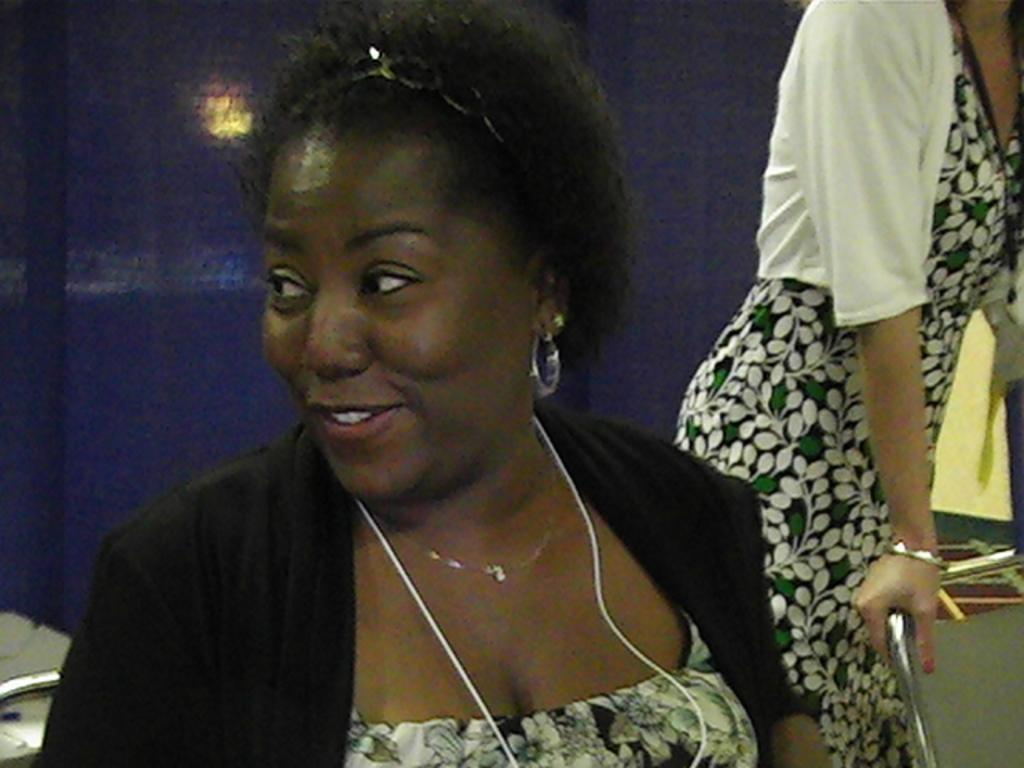How many people are in the image? There are persons in the image. What are the persons wearing? The persons are wearing clothes. Can you describe the position of a person in the image? There is a person on the right side of the image. What is the person on the right side holding? The person on the right side is holding a metal rod with her hand. What is the price of the machine in the image? There is no machine present in the image, so it is not possible to determine its price. 